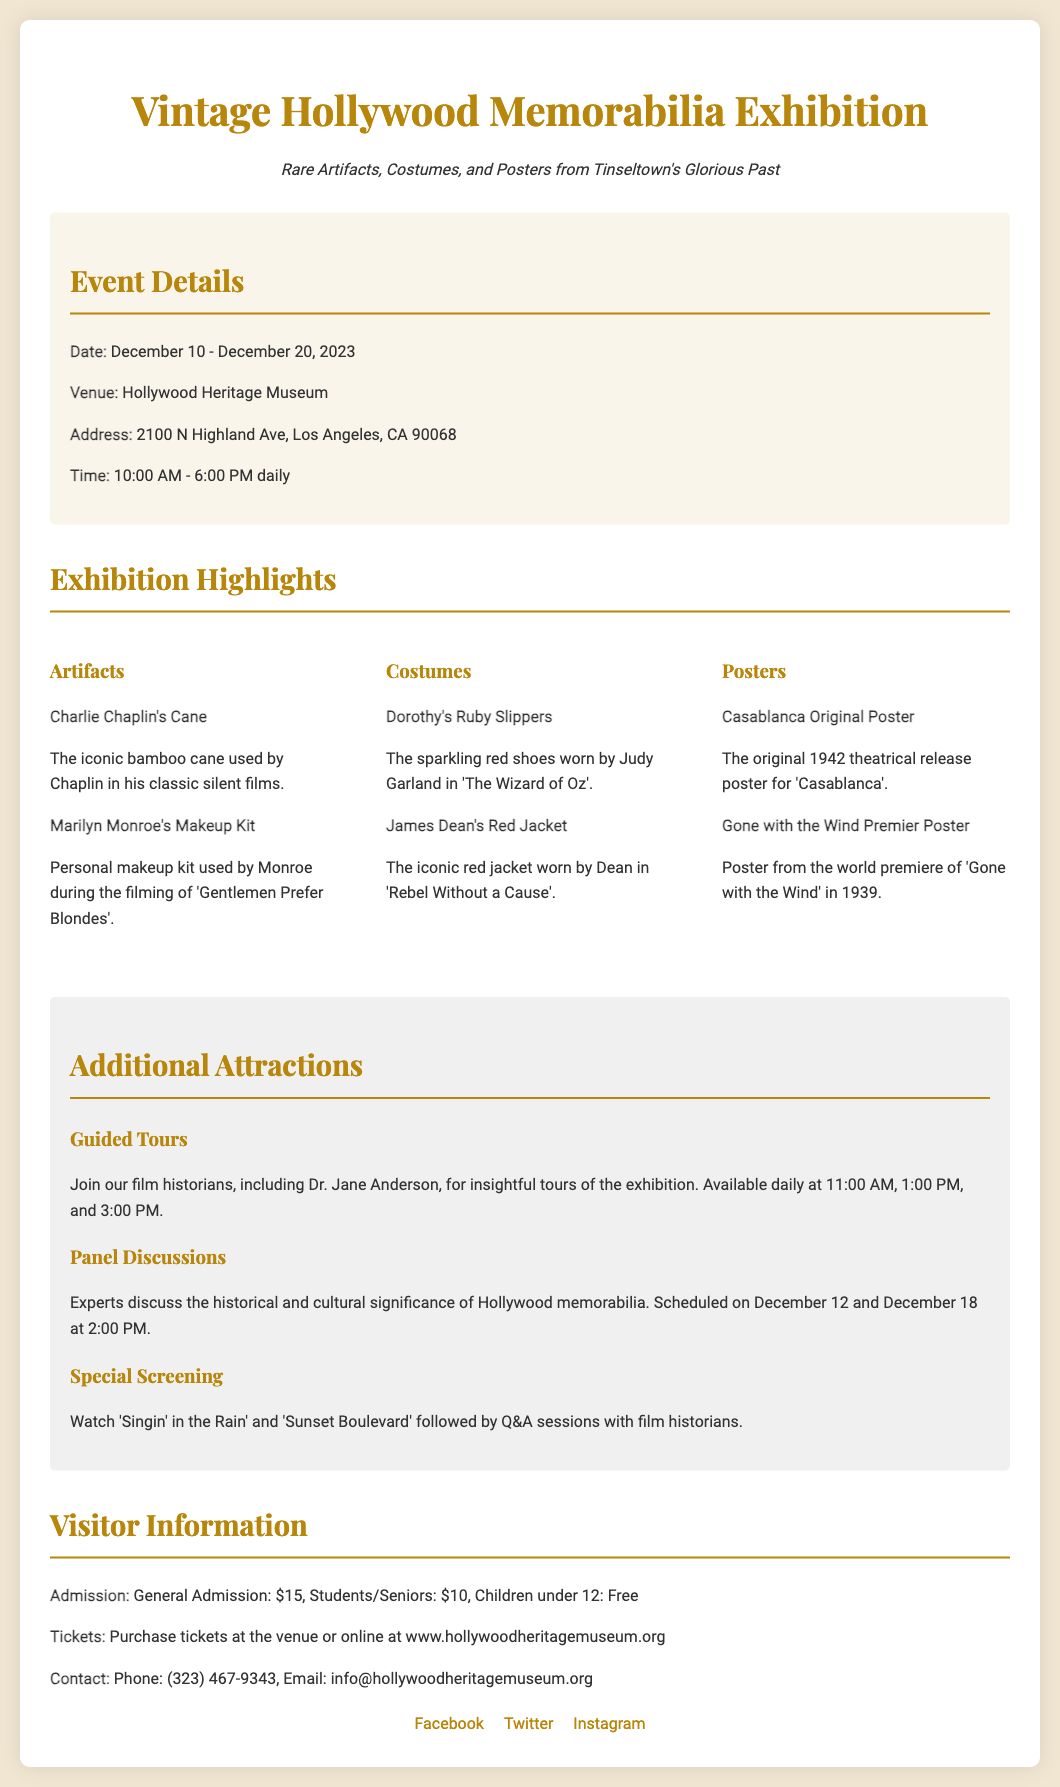What are the exhibition dates? The exhibition dates specified in the document are from December 10 to December 20, 2023.
Answer: December 10 - December 20, 2023 Where is the exhibition being held? The venue of the exhibition is clearly mentioned as the Hollywood Heritage Museum.
Answer: Hollywood Heritage Museum What is the admission fee for students? The document lists the admission price for students and seniors, which is stated in the visitor information section.
Answer: $10 Who hosted the special screening? The document refers to film historians leading the Q&A sessions after the screenings, indicating their involvement.
Answer: Film historians When are the guided tours available? The times for the guided tours are provided in the additional attractions section of the document.
Answer: 11:00 AM, 1:00 PM, and 3:00 PM What is one item from the artifacts section? An item from the artifacts category is mentioned, along with its associated description in the highlights section.
Answer: Charlie Chaplin's Cane How many panel discussions are scheduled? The document specifies the days when the panel discussions will occur, which helps deduce the number.
Answer: 2 What is the contact email for the museum? The contact information for the museum includes an email address, as stated in the visitor information.
Answer: info@hollywoodheritagemuseum.org Which film is featured in the special screening? The document lists two films that are part of the special screening along with the Q&A sessions.
Answer: Singin' in the Rain and Sunset Boulevard 